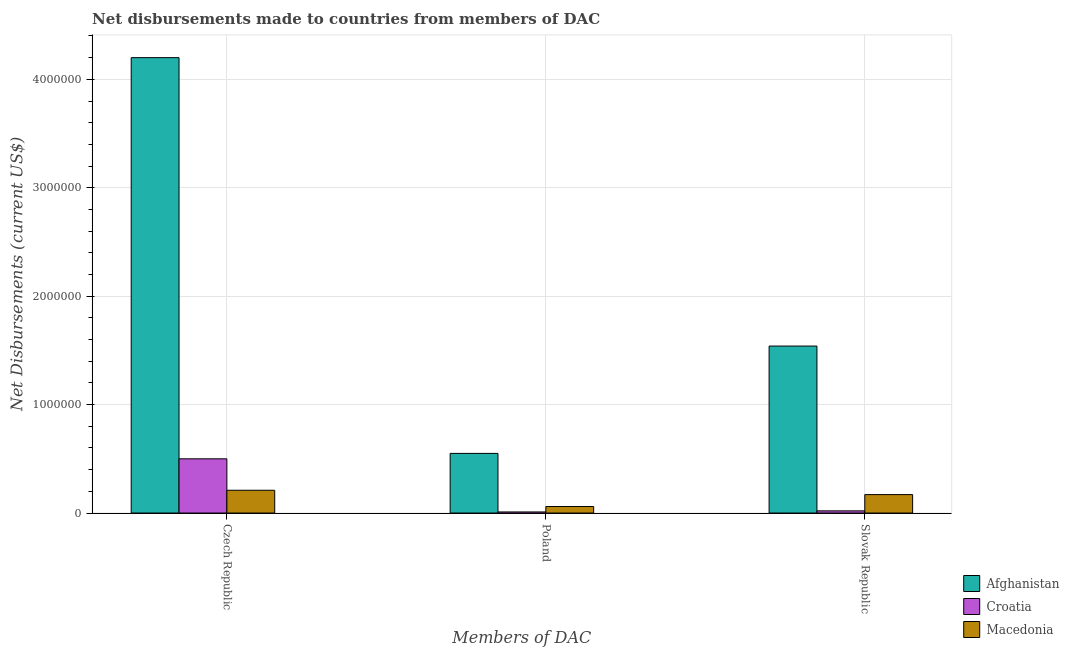How many different coloured bars are there?
Your response must be concise. 3. Are the number of bars on each tick of the X-axis equal?
Your answer should be very brief. Yes. How many bars are there on the 2nd tick from the left?
Provide a succinct answer. 3. How many bars are there on the 3rd tick from the right?
Keep it short and to the point. 3. What is the label of the 1st group of bars from the left?
Ensure brevity in your answer.  Czech Republic. What is the net disbursements made by poland in Croatia?
Offer a terse response. 10000. Across all countries, what is the maximum net disbursements made by slovak republic?
Offer a terse response. 1.54e+06. Across all countries, what is the minimum net disbursements made by poland?
Your answer should be very brief. 10000. In which country was the net disbursements made by poland maximum?
Keep it short and to the point. Afghanistan. In which country was the net disbursements made by slovak republic minimum?
Provide a short and direct response. Croatia. What is the total net disbursements made by slovak republic in the graph?
Offer a very short reply. 1.73e+06. What is the difference between the net disbursements made by poland in Macedonia and that in Croatia?
Provide a short and direct response. 5.00e+04. What is the difference between the net disbursements made by czech republic in Croatia and the net disbursements made by poland in Macedonia?
Keep it short and to the point. 4.40e+05. What is the average net disbursements made by poland per country?
Offer a terse response. 2.07e+05. What is the difference between the net disbursements made by slovak republic and net disbursements made by czech republic in Afghanistan?
Provide a short and direct response. -2.66e+06. What is the ratio of the net disbursements made by czech republic in Croatia to that in Macedonia?
Your answer should be compact. 2.38. Is the difference between the net disbursements made by poland in Macedonia and Afghanistan greater than the difference between the net disbursements made by czech republic in Macedonia and Afghanistan?
Ensure brevity in your answer.  Yes. What is the difference between the highest and the second highest net disbursements made by poland?
Keep it short and to the point. 4.90e+05. What is the difference between the highest and the lowest net disbursements made by poland?
Offer a very short reply. 5.40e+05. In how many countries, is the net disbursements made by poland greater than the average net disbursements made by poland taken over all countries?
Ensure brevity in your answer.  1. What does the 1st bar from the left in Czech Republic represents?
Ensure brevity in your answer.  Afghanistan. What does the 3rd bar from the right in Czech Republic represents?
Provide a short and direct response. Afghanistan. Is it the case that in every country, the sum of the net disbursements made by czech republic and net disbursements made by poland is greater than the net disbursements made by slovak republic?
Keep it short and to the point. Yes. How many bars are there?
Your answer should be very brief. 9. Are all the bars in the graph horizontal?
Make the answer very short. No. What is the title of the graph?
Your answer should be compact. Net disbursements made to countries from members of DAC. Does "Saudi Arabia" appear as one of the legend labels in the graph?
Provide a succinct answer. No. What is the label or title of the X-axis?
Make the answer very short. Members of DAC. What is the label or title of the Y-axis?
Give a very brief answer. Net Disbursements (current US$). What is the Net Disbursements (current US$) of Afghanistan in Czech Republic?
Ensure brevity in your answer.  4.20e+06. What is the Net Disbursements (current US$) of Croatia in Czech Republic?
Your answer should be very brief. 5.00e+05. What is the Net Disbursements (current US$) of Macedonia in Czech Republic?
Your response must be concise. 2.10e+05. What is the Net Disbursements (current US$) in Afghanistan in Poland?
Your answer should be compact. 5.50e+05. What is the Net Disbursements (current US$) in Croatia in Poland?
Make the answer very short. 10000. What is the Net Disbursements (current US$) of Macedonia in Poland?
Keep it short and to the point. 6.00e+04. What is the Net Disbursements (current US$) in Afghanistan in Slovak Republic?
Keep it short and to the point. 1.54e+06. What is the Net Disbursements (current US$) in Croatia in Slovak Republic?
Your response must be concise. 2.00e+04. Across all Members of DAC, what is the maximum Net Disbursements (current US$) in Afghanistan?
Make the answer very short. 4.20e+06. Across all Members of DAC, what is the maximum Net Disbursements (current US$) of Croatia?
Your response must be concise. 5.00e+05. Across all Members of DAC, what is the maximum Net Disbursements (current US$) in Macedonia?
Ensure brevity in your answer.  2.10e+05. What is the total Net Disbursements (current US$) in Afghanistan in the graph?
Offer a very short reply. 6.29e+06. What is the total Net Disbursements (current US$) in Croatia in the graph?
Your answer should be very brief. 5.30e+05. What is the total Net Disbursements (current US$) in Macedonia in the graph?
Your response must be concise. 4.40e+05. What is the difference between the Net Disbursements (current US$) of Afghanistan in Czech Republic and that in Poland?
Give a very brief answer. 3.65e+06. What is the difference between the Net Disbursements (current US$) of Afghanistan in Czech Republic and that in Slovak Republic?
Keep it short and to the point. 2.66e+06. What is the difference between the Net Disbursements (current US$) in Macedonia in Czech Republic and that in Slovak Republic?
Your response must be concise. 4.00e+04. What is the difference between the Net Disbursements (current US$) in Afghanistan in Poland and that in Slovak Republic?
Ensure brevity in your answer.  -9.90e+05. What is the difference between the Net Disbursements (current US$) of Croatia in Poland and that in Slovak Republic?
Make the answer very short. -10000. What is the difference between the Net Disbursements (current US$) in Afghanistan in Czech Republic and the Net Disbursements (current US$) in Croatia in Poland?
Offer a terse response. 4.19e+06. What is the difference between the Net Disbursements (current US$) in Afghanistan in Czech Republic and the Net Disbursements (current US$) in Macedonia in Poland?
Give a very brief answer. 4.14e+06. What is the difference between the Net Disbursements (current US$) of Croatia in Czech Republic and the Net Disbursements (current US$) of Macedonia in Poland?
Ensure brevity in your answer.  4.40e+05. What is the difference between the Net Disbursements (current US$) of Afghanistan in Czech Republic and the Net Disbursements (current US$) of Croatia in Slovak Republic?
Your answer should be very brief. 4.18e+06. What is the difference between the Net Disbursements (current US$) of Afghanistan in Czech Republic and the Net Disbursements (current US$) of Macedonia in Slovak Republic?
Provide a short and direct response. 4.03e+06. What is the difference between the Net Disbursements (current US$) of Afghanistan in Poland and the Net Disbursements (current US$) of Croatia in Slovak Republic?
Give a very brief answer. 5.30e+05. What is the difference between the Net Disbursements (current US$) of Afghanistan in Poland and the Net Disbursements (current US$) of Macedonia in Slovak Republic?
Offer a very short reply. 3.80e+05. What is the average Net Disbursements (current US$) of Afghanistan per Members of DAC?
Your answer should be very brief. 2.10e+06. What is the average Net Disbursements (current US$) in Croatia per Members of DAC?
Your response must be concise. 1.77e+05. What is the average Net Disbursements (current US$) of Macedonia per Members of DAC?
Ensure brevity in your answer.  1.47e+05. What is the difference between the Net Disbursements (current US$) of Afghanistan and Net Disbursements (current US$) of Croatia in Czech Republic?
Offer a terse response. 3.70e+06. What is the difference between the Net Disbursements (current US$) of Afghanistan and Net Disbursements (current US$) of Macedonia in Czech Republic?
Provide a succinct answer. 3.99e+06. What is the difference between the Net Disbursements (current US$) of Afghanistan and Net Disbursements (current US$) of Croatia in Poland?
Make the answer very short. 5.40e+05. What is the difference between the Net Disbursements (current US$) in Afghanistan and Net Disbursements (current US$) in Macedonia in Poland?
Keep it short and to the point. 4.90e+05. What is the difference between the Net Disbursements (current US$) in Afghanistan and Net Disbursements (current US$) in Croatia in Slovak Republic?
Offer a very short reply. 1.52e+06. What is the difference between the Net Disbursements (current US$) of Afghanistan and Net Disbursements (current US$) of Macedonia in Slovak Republic?
Ensure brevity in your answer.  1.37e+06. What is the ratio of the Net Disbursements (current US$) in Afghanistan in Czech Republic to that in Poland?
Offer a terse response. 7.64. What is the ratio of the Net Disbursements (current US$) of Macedonia in Czech Republic to that in Poland?
Keep it short and to the point. 3.5. What is the ratio of the Net Disbursements (current US$) of Afghanistan in Czech Republic to that in Slovak Republic?
Your answer should be very brief. 2.73. What is the ratio of the Net Disbursements (current US$) of Croatia in Czech Republic to that in Slovak Republic?
Your answer should be very brief. 25. What is the ratio of the Net Disbursements (current US$) of Macedonia in Czech Republic to that in Slovak Republic?
Provide a short and direct response. 1.24. What is the ratio of the Net Disbursements (current US$) of Afghanistan in Poland to that in Slovak Republic?
Offer a terse response. 0.36. What is the ratio of the Net Disbursements (current US$) of Macedonia in Poland to that in Slovak Republic?
Your response must be concise. 0.35. What is the difference between the highest and the second highest Net Disbursements (current US$) in Afghanistan?
Give a very brief answer. 2.66e+06. What is the difference between the highest and the lowest Net Disbursements (current US$) of Afghanistan?
Provide a succinct answer. 3.65e+06. What is the difference between the highest and the lowest Net Disbursements (current US$) of Macedonia?
Your answer should be very brief. 1.50e+05. 